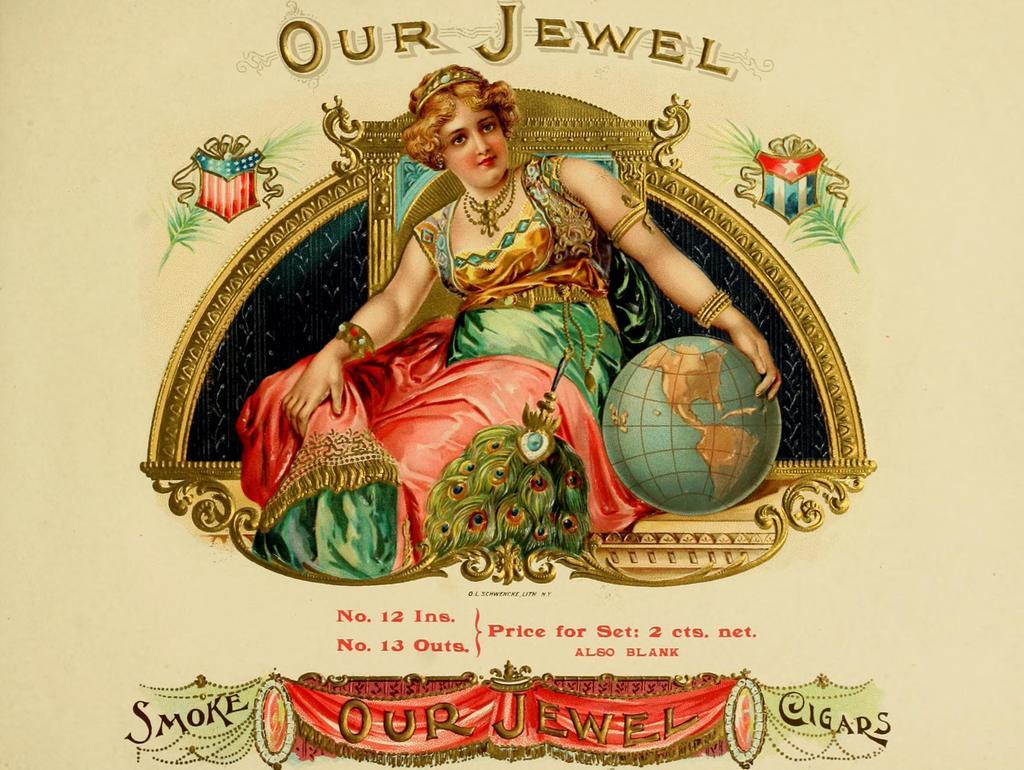What is present in the image that features a design or message? There is a poster in the image. What is depicted on the poster? The poster features a woman. What else can be seen on the poster besides the image of the woman? There is text written on the poster. Is the room in the image quiet or noisy? The provided facts do not mention any information about the noise level in the room, so it cannot be determined from the image. 